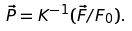Convert formula to latex. <formula><loc_0><loc_0><loc_500><loc_500>\vec { P } = { K } ^ { - 1 } ( \vec { F } / F _ { 0 } ) .</formula> 